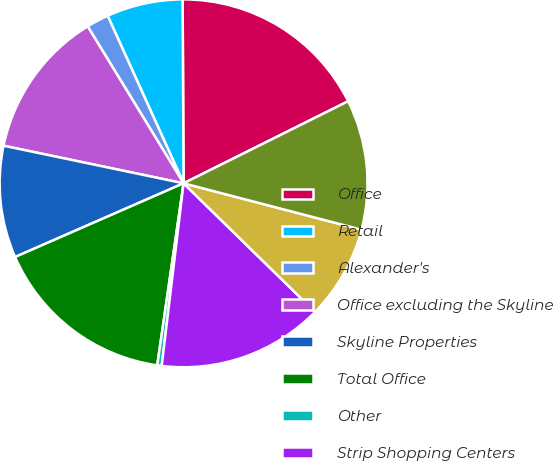<chart> <loc_0><loc_0><loc_500><loc_500><pie_chart><fcel>Office<fcel>Retail<fcel>Alexander's<fcel>Office excluding the Skyline<fcel>Skyline Properties<fcel>Total Office<fcel>Other<fcel>Strip Shopping Centers<fcel>Regional Malls<fcel>The Mart<nl><fcel>17.72%<fcel>6.69%<fcel>1.96%<fcel>12.99%<fcel>9.84%<fcel>16.15%<fcel>0.39%<fcel>14.57%<fcel>8.27%<fcel>11.42%<nl></chart> 